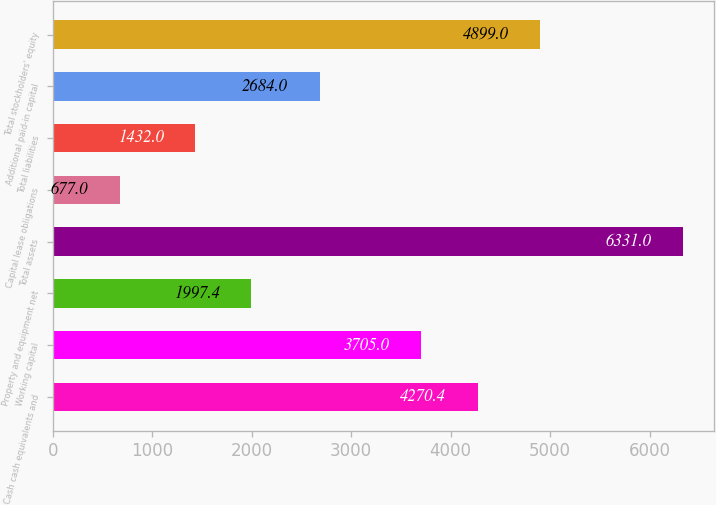Convert chart. <chart><loc_0><loc_0><loc_500><loc_500><bar_chart><fcel>Cash cash equivalents and<fcel>Working capital<fcel>Property and equipment net<fcel>Total assets<fcel>Capital lease obligations<fcel>Total liabilities<fcel>Additional paid-in capital<fcel>Total stockholders' equity<nl><fcel>4270.4<fcel>3705<fcel>1997.4<fcel>6331<fcel>677<fcel>1432<fcel>2684<fcel>4899<nl></chart> 